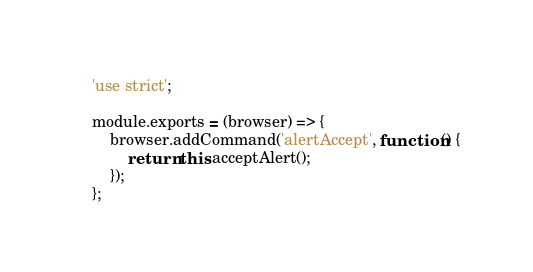<code> <loc_0><loc_0><loc_500><loc_500><_JavaScript_>'use strict';

module.exports = (browser) => {
    browser.addCommand('alertAccept', function() {
        return this.acceptAlert();
    });
};
</code> 